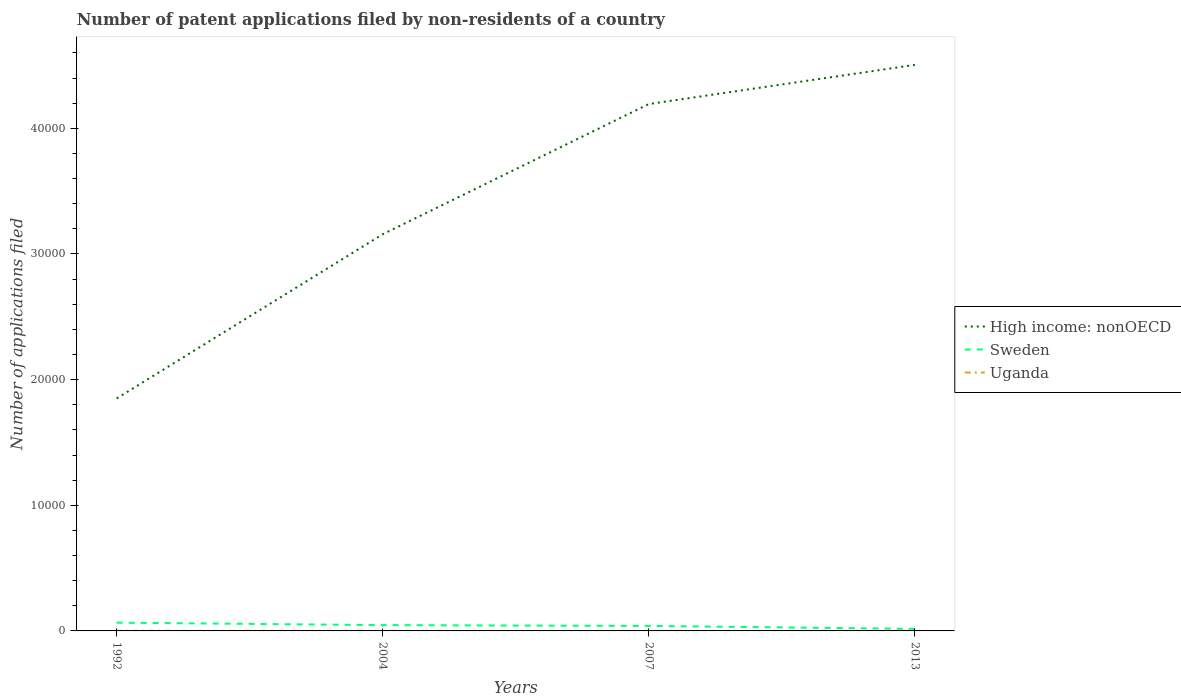How many different coloured lines are there?
Your answer should be compact. 3. Does the line corresponding to Sweden intersect with the line corresponding to Uganda?
Your answer should be very brief. No. Across all years, what is the maximum number of applications filed in High income: nonOECD?
Your answer should be very brief. 1.85e+04. In which year was the number of applications filed in Sweden maximum?
Offer a very short reply. 2013. What is the total number of applications filed in Uganda in the graph?
Your response must be concise. -3. What is the difference between the highest and the second highest number of applications filed in Uganda?
Make the answer very short. 10. What is the difference between the highest and the lowest number of applications filed in High income: nonOECD?
Your response must be concise. 2. Is the number of applications filed in Uganda strictly greater than the number of applications filed in High income: nonOECD over the years?
Make the answer very short. Yes. How many lines are there?
Your response must be concise. 3. Are the values on the major ticks of Y-axis written in scientific E-notation?
Ensure brevity in your answer.  No. Does the graph contain any zero values?
Offer a terse response. No. Does the graph contain grids?
Your answer should be compact. No. Where does the legend appear in the graph?
Keep it short and to the point. Center right. What is the title of the graph?
Make the answer very short. Number of patent applications filed by non-residents of a country. Does "South Sudan" appear as one of the legend labels in the graph?
Offer a terse response. No. What is the label or title of the X-axis?
Ensure brevity in your answer.  Years. What is the label or title of the Y-axis?
Give a very brief answer. Number of applications filed. What is the Number of applications filed in High income: nonOECD in 1992?
Your answer should be very brief. 1.85e+04. What is the Number of applications filed of Sweden in 1992?
Your response must be concise. 657. What is the Number of applications filed in High income: nonOECD in 2004?
Your response must be concise. 3.16e+04. What is the Number of applications filed of Sweden in 2004?
Offer a very short reply. 462. What is the Number of applications filed in Uganda in 2004?
Ensure brevity in your answer.  1. What is the Number of applications filed in High income: nonOECD in 2007?
Your answer should be very brief. 4.19e+04. What is the Number of applications filed of Sweden in 2007?
Give a very brief answer. 398. What is the Number of applications filed in Uganda in 2007?
Offer a very short reply. 1. What is the Number of applications filed of High income: nonOECD in 2013?
Your answer should be compact. 4.51e+04. What is the Number of applications filed of Sweden in 2013?
Provide a succinct answer. 163. What is the Number of applications filed in Uganda in 2013?
Make the answer very short. 4. Across all years, what is the maximum Number of applications filed in High income: nonOECD?
Your response must be concise. 4.51e+04. Across all years, what is the maximum Number of applications filed of Sweden?
Ensure brevity in your answer.  657. Across all years, what is the maximum Number of applications filed in Uganda?
Offer a very short reply. 11. Across all years, what is the minimum Number of applications filed in High income: nonOECD?
Your response must be concise. 1.85e+04. Across all years, what is the minimum Number of applications filed in Sweden?
Ensure brevity in your answer.  163. What is the total Number of applications filed of High income: nonOECD in the graph?
Provide a succinct answer. 1.37e+05. What is the total Number of applications filed of Sweden in the graph?
Keep it short and to the point. 1680. What is the total Number of applications filed of Uganda in the graph?
Give a very brief answer. 17. What is the difference between the Number of applications filed in High income: nonOECD in 1992 and that in 2004?
Your answer should be very brief. -1.31e+04. What is the difference between the Number of applications filed of Sweden in 1992 and that in 2004?
Your answer should be very brief. 195. What is the difference between the Number of applications filed of High income: nonOECD in 1992 and that in 2007?
Offer a terse response. -2.34e+04. What is the difference between the Number of applications filed in Sweden in 1992 and that in 2007?
Offer a very short reply. 259. What is the difference between the Number of applications filed of Uganda in 1992 and that in 2007?
Offer a very short reply. 10. What is the difference between the Number of applications filed in High income: nonOECD in 1992 and that in 2013?
Make the answer very short. -2.65e+04. What is the difference between the Number of applications filed in Sweden in 1992 and that in 2013?
Offer a terse response. 494. What is the difference between the Number of applications filed in Uganda in 1992 and that in 2013?
Your answer should be compact. 7. What is the difference between the Number of applications filed of High income: nonOECD in 2004 and that in 2007?
Give a very brief answer. -1.04e+04. What is the difference between the Number of applications filed in Uganda in 2004 and that in 2007?
Provide a succinct answer. 0. What is the difference between the Number of applications filed of High income: nonOECD in 2004 and that in 2013?
Your answer should be very brief. -1.35e+04. What is the difference between the Number of applications filed of Sweden in 2004 and that in 2013?
Keep it short and to the point. 299. What is the difference between the Number of applications filed of High income: nonOECD in 2007 and that in 2013?
Make the answer very short. -3118. What is the difference between the Number of applications filed of Sweden in 2007 and that in 2013?
Ensure brevity in your answer.  235. What is the difference between the Number of applications filed of High income: nonOECD in 1992 and the Number of applications filed of Sweden in 2004?
Your response must be concise. 1.80e+04. What is the difference between the Number of applications filed of High income: nonOECD in 1992 and the Number of applications filed of Uganda in 2004?
Provide a succinct answer. 1.85e+04. What is the difference between the Number of applications filed of Sweden in 1992 and the Number of applications filed of Uganda in 2004?
Offer a terse response. 656. What is the difference between the Number of applications filed in High income: nonOECD in 1992 and the Number of applications filed in Sweden in 2007?
Ensure brevity in your answer.  1.81e+04. What is the difference between the Number of applications filed of High income: nonOECD in 1992 and the Number of applications filed of Uganda in 2007?
Ensure brevity in your answer.  1.85e+04. What is the difference between the Number of applications filed of Sweden in 1992 and the Number of applications filed of Uganda in 2007?
Provide a succinct answer. 656. What is the difference between the Number of applications filed in High income: nonOECD in 1992 and the Number of applications filed in Sweden in 2013?
Ensure brevity in your answer.  1.83e+04. What is the difference between the Number of applications filed of High income: nonOECD in 1992 and the Number of applications filed of Uganda in 2013?
Your answer should be compact. 1.85e+04. What is the difference between the Number of applications filed of Sweden in 1992 and the Number of applications filed of Uganda in 2013?
Give a very brief answer. 653. What is the difference between the Number of applications filed in High income: nonOECD in 2004 and the Number of applications filed in Sweden in 2007?
Your response must be concise. 3.12e+04. What is the difference between the Number of applications filed in High income: nonOECD in 2004 and the Number of applications filed in Uganda in 2007?
Give a very brief answer. 3.16e+04. What is the difference between the Number of applications filed of Sweden in 2004 and the Number of applications filed of Uganda in 2007?
Keep it short and to the point. 461. What is the difference between the Number of applications filed in High income: nonOECD in 2004 and the Number of applications filed in Sweden in 2013?
Your response must be concise. 3.14e+04. What is the difference between the Number of applications filed of High income: nonOECD in 2004 and the Number of applications filed of Uganda in 2013?
Ensure brevity in your answer.  3.16e+04. What is the difference between the Number of applications filed in Sweden in 2004 and the Number of applications filed in Uganda in 2013?
Your answer should be very brief. 458. What is the difference between the Number of applications filed in High income: nonOECD in 2007 and the Number of applications filed in Sweden in 2013?
Your answer should be compact. 4.18e+04. What is the difference between the Number of applications filed of High income: nonOECD in 2007 and the Number of applications filed of Uganda in 2013?
Keep it short and to the point. 4.19e+04. What is the difference between the Number of applications filed of Sweden in 2007 and the Number of applications filed of Uganda in 2013?
Offer a terse response. 394. What is the average Number of applications filed in High income: nonOECD per year?
Give a very brief answer. 3.43e+04. What is the average Number of applications filed of Sweden per year?
Ensure brevity in your answer.  420. What is the average Number of applications filed of Uganda per year?
Your answer should be compact. 4.25. In the year 1992, what is the difference between the Number of applications filed in High income: nonOECD and Number of applications filed in Sweden?
Offer a very short reply. 1.78e+04. In the year 1992, what is the difference between the Number of applications filed of High income: nonOECD and Number of applications filed of Uganda?
Your answer should be very brief. 1.85e+04. In the year 1992, what is the difference between the Number of applications filed in Sweden and Number of applications filed in Uganda?
Make the answer very short. 646. In the year 2004, what is the difference between the Number of applications filed of High income: nonOECD and Number of applications filed of Sweden?
Provide a short and direct response. 3.11e+04. In the year 2004, what is the difference between the Number of applications filed of High income: nonOECD and Number of applications filed of Uganda?
Make the answer very short. 3.16e+04. In the year 2004, what is the difference between the Number of applications filed of Sweden and Number of applications filed of Uganda?
Offer a very short reply. 461. In the year 2007, what is the difference between the Number of applications filed of High income: nonOECD and Number of applications filed of Sweden?
Your answer should be compact. 4.15e+04. In the year 2007, what is the difference between the Number of applications filed in High income: nonOECD and Number of applications filed in Uganda?
Give a very brief answer. 4.19e+04. In the year 2007, what is the difference between the Number of applications filed in Sweden and Number of applications filed in Uganda?
Give a very brief answer. 397. In the year 2013, what is the difference between the Number of applications filed in High income: nonOECD and Number of applications filed in Sweden?
Provide a short and direct response. 4.49e+04. In the year 2013, what is the difference between the Number of applications filed of High income: nonOECD and Number of applications filed of Uganda?
Your answer should be compact. 4.50e+04. In the year 2013, what is the difference between the Number of applications filed of Sweden and Number of applications filed of Uganda?
Keep it short and to the point. 159. What is the ratio of the Number of applications filed of High income: nonOECD in 1992 to that in 2004?
Ensure brevity in your answer.  0.59. What is the ratio of the Number of applications filed in Sweden in 1992 to that in 2004?
Offer a terse response. 1.42. What is the ratio of the Number of applications filed in High income: nonOECD in 1992 to that in 2007?
Your answer should be very brief. 0.44. What is the ratio of the Number of applications filed of Sweden in 1992 to that in 2007?
Keep it short and to the point. 1.65. What is the ratio of the Number of applications filed of High income: nonOECD in 1992 to that in 2013?
Ensure brevity in your answer.  0.41. What is the ratio of the Number of applications filed in Sweden in 1992 to that in 2013?
Provide a succinct answer. 4.03. What is the ratio of the Number of applications filed in Uganda in 1992 to that in 2013?
Your response must be concise. 2.75. What is the ratio of the Number of applications filed of High income: nonOECD in 2004 to that in 2007?
Give a very brief answer. 0.75. What is the ratio of the Number of applications filed of Sweden in 2004 to that in 2007?
Keep it short and to the point. 1.16. What is the ratio of the Number of applications filed in Uganda in 2004 to that in 2007?
Offer a terse response. 1. What is the ratio of the Number of applications filed of High income: nonOECD in 2004 to that in 2013?
Your answer should be very brief. 0.7. What is the ratio of the Number of applications filed of Sweden in 2004 to that in 2013?
Your answer should be compact. 2.83. What is the ratio of the Number of applications filed in Uganda in 2004 to that in 2013?
Keep it short and to the point. 0.25. What is the ratio of the Number of applications filed in High income: nonOECD in 2007 to that in 2013?
Your response must be concise. 0.93. What is the ratio of the Number of applications filed in Sweden in 2007 to that in 2013?
Offer a terse response. 2.44. What is the difference between the highest and the second highest Number of applications filed of High income: nonOECD?
Keep it short and to the point. 3118. What is the difference between the highest and the second highest Number of applications filed in Sweden?
Provide a succinct answer. 195. What is the difference between the highest and the lowest Number of applications filed in High income: nonOECD?
Offer a terse response. 2.65e+04. What is the difference between the highest and the lowest Number of applications filed in Sweden?
Offer a very short reply. 494. What is the difference between the highest and the lowest Number of applications filed in Uganda?
Provide a short and direct response. 10. 